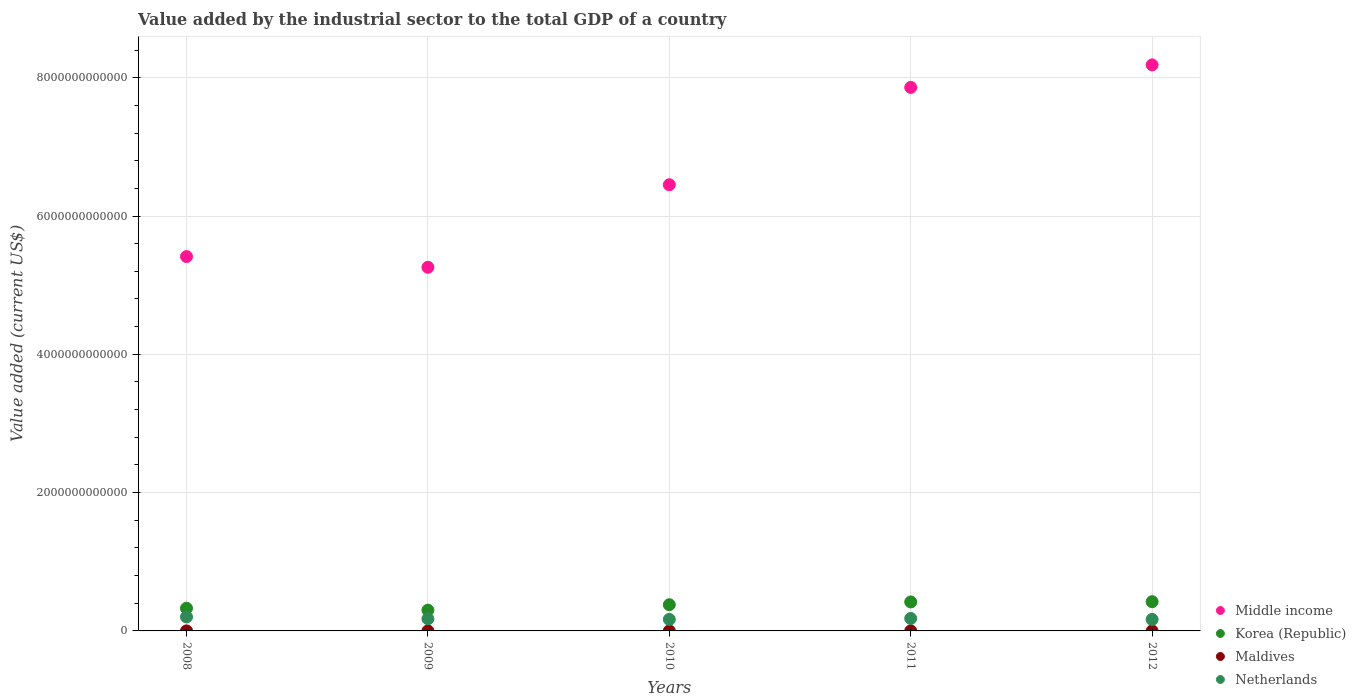Is the number of dotlines equal to the number of legend labels?
Provide a succinct answer. Yes. What is the value added by the industrial sector to the total GDP in Netherlands in 2010?
Provide a succinct answer. 1.66e+11. Across all years, what is the maximum value added by the industrial sector to the total GDP in Maldives?
Your answer should be very brief. 4.31e+08. Across all years, what is the minimum value added by the industrial sector to the total GDP in Middle income?
Make the answer very short. 5.26e+12. In which year was the value added by the industrial sector to the total GDP in Middle income minimum?
Your response must be concise. 2009. What is the total value added by the industrial sector to the total GDP in Korea (Republic) in the graph?
Keep it short and to the point. 1.85e+12. What is the difference between the value added by the industrial sector to the total GDP in Netherlands in 2008 and that in 2009?
Ensure brevity in your answer.  2.69e+1. What is the difference between the value added by the industrial sector to the total GDP in Netherlands in 2008 and the value added by the industrial sector to the total GDP in Maldives in 2012?
Give a very brief answer. 2.02e+11. What is the average value added by the industrial sector to the total GDP in Netherlands per year?
Provide a succinct answer. 1.78e+11. In the year 2012, what is the difference between the value added by the industrial sector to the total GDP in Korea (Republic) and value added by the industrial sector to the total GDP in Netherlands?
Provide a succinct answer. 2.57e+11. In how many years, is the value added by the industrial sector to the total GDP in Maldives greater than 4400000000000 US$?
Your answer should be compact. 0. What is the ratio of the value added by the industrial sector to the total GDP in Korea (Republic) in 2011 to that in 2012?
Offer a terse response. 0.99. What is the difference between the highest and the second highest value added by the industrial sector to the total GDP in Maldives?
Provide a succinct answer. 2.55e+07. What is the difference between the highest and the lowest value added by the industrial sector to the total GDP in Netherlands?
Your answer should be compact. 3.62e+1. Is the sum of the value added by the industrial sector to the total GDP in Middle income in 2010 and 2011 greater than the maximum value added by the industrial sector to the total GDP in Maldives across all years?
Make the answer very short. Yes. Is it the case that in every year, the sum of the value added by the industrial sector to the total GDP in Middle income and value added by the industrial sector to the total GDP in Korea (Republic)  is greater than the sum of value added by the industrial sector to the total GDP in Netherlands and value added by the industrial sector to the total GDP in Maldives?
Offer a very short reply. Yes. Is it the case that in every year, the sum of the value added by the industrial sector to the total GDP in Middle income and value added by the industrial sector to the total GDP in Korea (Republic)  is greater than the value added by the industrial sector to the total GDP in Maldives?
Ensure brevity in your answer.  Yes. Is the value added by the industrial sector to the total GDP in Maldives strictly greater than the value added by the industrial sector to the total GDP in Middle income over the years?
Your response must be concise. No. What is the difference between two consecutive major ticks on the Y-axis?
Keep it short and to the point. 2.00e+12. Does the graph contain grids?
Give a very brief answer. Yes. Where does the legend appear in the graph?
Offer a terse response. Bottom right. How many legend labels are there?
Offer a very short reply. 4. How are the legend labels stacked?
Ensure brevity in your answer.  Vertical. What is the title of the graph?
Provide a succinct answer. Value added by the industrial sector to the total GDP of a country. Does "Fiji" appear as one of the legend labels in the graph?
Your response must be concise. No. What is the label or title of the X-axis?
Your answer should be compact. Years. What is the label or title of the Y-axis?
Your answer should be compact. Value added (current US$). What is the Value added (current US$) in Middle income in 2008?
Your answer should be very brief. 5.41e+12. What is the Value added (current US$) of Korea (Republic) in 2008?
Your answer should be very brief. 3.28e+11. What is the Value added (current US$) of Maldives in 2008?
Ensure brevity in your answer.  3.41e+08. What is the Value added (current US$) of Netherlands in 2008?
Offer a very short reply. 2.02e+11. What is the Value added (current US$) of Middle income in 2009?
Keep it short and to the point. 5.26e+12. What is the Value added (current US$) of Korea (Republic) in 2009?
Your answer should be very brief. 3.00e+11. What is the Value added (current US$) of Maldives in 2009?
Your answer should be very brief. 2.99e+08. What is the Value added (current US$) of Netherlands in 2009?
Make the answer very short. 1.75e+11. What is the Value added (current US$) in Middle income in 2010?
Your answer should be compact. 6.45e+12. What is the Value added (current US$) of Korea (Republic) in 2010?
Offer a very short reply. 3.79e+11. What is the Value added (current US$) in Maldives in 2010?
Make the answer very short. 3.32e+08. What is the Value added (current US$) in Netherlands in 2010?
Provide a succinct answer. 1.66e+11. What is the Value added (current US$) of Middle income in 2011?
Your answer should be compact. 7.86e+12. What is the Value added (current US$) of Korea (Republic) in 2011?
Your answer should be very brief. 4.19e+11. What is the Value added (current US$) in Maldives in 2011?
Offer a very short reply. 4.06e+08. What is the Value added (current US$) of Netherlands in 2011?
Make the answer very short. 1.80e+11. What is the Value added (current US$) in Middle income in 2012?
Make the answer very short. 8.19e+12. What is the Value added (current US$) of Korea (Republic) in 2012?
Make the answer very short. 4.23e+11. What is the Value added (current US$) of Maldives in 2012?
Your answer should be very brief. 4.31e+08. What is the Value added (current US$) in Netherlands in 2012?
Provide a succinct answer. 1.66e+11. Across all years, what is the maximum Value added (current US$) of Middle income?
Offer a terse response. 8.19e+12. Across all years, what is the maximum Value added (current US$) in Korea (Republic)?
Offer a very short reply. 4.23e+11. Across all years, what is the maximum Value added (current US$) of Maldives?
Offer a very short reply. 4.31e+08. Across all years, what is the maximum Value added (current US$) of Netherlands?
Make the answer very short. 2.02e+11. Across all years, what is the minimum Value added (current US$) in Middle income?
Keep it short and to the point. 5.26e+12. Across all years, what is the minimum Value added (current US$) of Korea (Republic)?
Offer a very short reply. 3.00e+11. Across all years, what is the minimum Value added (current US$) in Maldives?
Ensure brevity in your answer.  2.99e+08. Across all years, what is the minimum Value added (current US$) of Netherlands?
Offer a very short reply. 1.66e+11. What is the total Value added (current US$) of Middle income in the graph?
Provide a succinct answer. 3.32e+13. What is the total Value added (current US$) in Korea (Republic) in the graph?
Your answer should be compact. 1.85e+12. What is the total Value added (current US$) in Maldives in the graph?
Give a very brief answer. 1.81e+09. What is the total Value added (current US$) in Netherlands in the graph?
Your response must be concise. 8.91e+11. What is the difference between the Value added (current US$) of Middle income in 2008 and that in 2009?
Offer a very short reply. 1.55e+11. What is the difference between the Value added (current US$) in Korea (Republic) in 2008 and that in 2009?
Your response must be concise. 2.79e+1. What is the difference between the Value added (current US$) in Maldives in 2008 and that in 2009?
Your answer should be very brief. 4.22e+07. What is the difference between the Value added (current US$) of Netherlands in 2008 and that in 2009?
Ensure brevity in your answer.  2.69e+1. What is the difference between the Value added (current US$) of Middle income in 2008 and that in 2010?
Your answer should be compact. -1.04e+12. What is the difference between the Value added (current US$) in Korea (Republic) in 2008 and that in 2010?
Keep it short and to the point. -5.11e+1. What is the difference between the Value added (current US$) of Maldives in 2008 and that in 2010?
Provide a succinct answer. 9.53e+06. What is the difference between the Value added (current US$) of Netherlands in 2008 and that in 2010?
Give a very brief answer. 3.58e+1. What is the difference between the Value added (current US$) in Middle income in 2008 and that in 2011?
Ensure brevity in your answer.  -2.45e+12. What is the difference between the Value added (current US$) of Korea (Republic) in 2008 and that in 2011?
Offer a very short reply. -9.11e+1. What is the difference between the Value added (current US$) in Maldives in 2008 and that in 2011?
Keep it short and to the point. -6.45e+07. What is the difference between the Value added (current US$) in Netherlands in 2008 and that in 2011?
Provide a succinct answer. 2.19e+1. What is the difference between the Value added (current US$) in Middle income in 2008 and that in 2012?
Keep it short and to the point. -2.77e+12. What is the difference between the Value added (current US$) in Korea (Republic) in 2008 and that in 2012?
Give a very brief answer. -9.50e+1. What is the difference between the Value added (current US$) of Maldives in 2008 and that in 2012?
Provide a succinct answer. -9.00e+07. What is the difference between the Value added (current US$) in Netherlands in 2008 and that in 2012?
Provide a short and direct response. 3.62e+1. What is the difference between the Value added (current US$) of Middle income in 2009 and that in 2010?
Offer a terse response. -1.19e+12. What is the difference between the Value added (current US$) of Korea (Republic) in 2009 and that in 2010?
Keep it short and to the point. -7.90e+1. What is the difference between the Value added (current US$) in Maldives in 2009 and that in 2010?
Your answer should be compact. -3.27e+07. What is the difference between the Value added (current US$) of Netherlands in 2009 and that in 2010?
Offer a terse response. 8.91e+09. What is the difference between the Value added (current US$) of Middle income in 2009 and that in 2011?
Provide a short and direct response. -2.60e+12. What is the difference between the Value added (current US$) in Korea (Republic) in 2009 and that in 2011?
Make the answer very short. -1.19e+11. What is the difference between the Value added (current US$) in Maldives in 2009 and that in 2011?
Your response must be concise. -1.07e+08. What is the difference between the Value added (current US$) in Netherlands in 2009 and that in 2011?
Offer a terse response. -5.02e+09. What is the difference between the Value added (current US$) in Middle income in 2009 and that in 2012?
Give a very brief answer. -2.93e+12. What is the difference between the Value added (current US$) of Korea (Republic) in 2009 and that in 2012?
Offer a very short reply. -1.23e+11. What is the difference between the Value added (current US$) in Maldives in 2009 and that in 2012?
Offer a very short reply. -1.32e+08. What is the difference between the Value added (current US$) of Netherlands in 2009 and that in 2012?
Your answer should be very brief. 9.27e+09. What is the difference between the Value added (current US$) in Middle income in 2010 and that in 2011?
Offer a very short reply. -1.41e+12. What is the difference between the Value added (current US$) of Korea (Republic) in 2010 and that in 2011?
Offer a very short reply. -3.99e+1. What is the difference between the Value added (current US$) in Maldives in 2010 and that in 2011?
Offer a very short reply. -7.41e+07. What is the difference between the Value added (current US$) in Netherlands in 2010 and that in 2011?
Give a very brief answer. -1.39e+1. What is the difference between the Value added (current US$) of Middle income in 2010 and that in 2012?
Your answer should be compact. -1.73e+12. What is the difference between the Value added (current US$) in Korea (Republic) in 2010 and that in 2012?
Your answer should be compact. -4.39e+1. What is the difference between the Value added (current US$) in Maldives in 2010 and that in 2012?
Provide a succinct answer. -9.95e+07. What is the difference between the Value added (current US$) in Netherlands in 2010 and that in 2012?
Make the answer very short. 3.54e+08. What is the difference between the Value added (current US$) of Middle income in 2011 and that in 2012?
Ensure brevity in your answer.  -3.26e+11. What is the difference between the Value added (current US$) in Korea (Republic) in 2011 and that in 2012?
Offer a terse response. -3.92e+09. What is the difference between the Value added (current US$) of Maldives in 2011 and that in 2012?
Provide a short and direct response. -2.55e+07. What is the difference between the Value added (current US$) in Netherlands in 2011 and that in 2012?
Your response must be concise. 1.43e+1. What is the difference between the Value added (current US$) of Middle income in 2008 and the Value added (current US$) of Korea (Republic) in 2009?
Keep it short and to the point. 5.11e+12. What is the difference between the Value added (current US$) of Middle income in 2008 and the Value added (current US$) of Maldives in 2009?
Your answer should be compact. 5.41e+12. What is the difference between the Value added (current US$) in Middle income in 2008 and the Value added (current US$) in Netherlands in 2009?
Ensure brevity in your answer.  5.24e+12. What is the difference between the Value added (current US$) in Korea (Republic) in 2008 and the Value added (current US$) in Maldives in 2009?
Offer a very short reply. 3.28e+11. What is the difference between the Value added (current US$) in Korea (Republic) in 2008 and the Value added (current US$) in Netherlands in 2009?
Your answer should be very brief. 1.53e+11. What is the difference between the Value added (current US$) in Maldives in 2008 and the Value added (current US$) in Netherlands in 2009?
Offer a very short reply. -1.75e+11. What is the difference between the Value added (current US$) of Middle income in 2008 and the Value added (current US$) of Korea (Republic) in 2010?
Provide a succinct answer. 5.03e+12. What is the difference between the Value added (current US$) of Middle income in 2008 and the Value added (current US$) of Maldives in 2010?
Provide a short and direct response. 5.41e+12. What is the difference between the Value added (current US$) in Middle income in 2008 and the Value added (current US$) in Netherlands in 2010?
Offer a very short reply. 5.25e+12. What is the difference between the Value added (current US$) in Korea (Republic) in 2008 and the Value added (current US$) in Maldives in 2010?
Provide a succinct answer. 3.28e+11. What is the difference between the Value added (current US$) in Korea (Republic) in 2008 and the Value added (current US$) in Netherlands in 2010?
Provide a short and direct response. 1.61e+11. What is the difference between the Value added (current US$) in Maldives in 2008 and the Value added (current US$) in Netherlands in 2010?
Offer a terse response. -1.66e+11. What is the difference between the Value added (current US$) in Middle income in 2008 and the Value added (current US$) in Korea (Republic) in 2011?
Your answer should be very brief. 4.99e+12. What is the difference between the Value added (current US$) in Middle income in 2008 and the Value added (current US$) in Maldives in 2011?
Your answer should be compact. 5.41e+12. What is the difference between the Value added (current US$) in Middle income in 2008 and the Value added (current US$) in Netherlands in 2011?
Give a very brief answer. 5.23e+12. What is the difference between the Value added (current US$) of Korea (Republic) in 2008 and the Value added (current US$) of Maldives in 2011?
Keep it short and to the point. 3.28e+11. What is the difference between the Value added (current US$) of Korea (Republic) in 2008 and the Value added (current US$) of Netherlands in 2011?
Provide a succinct answer. 1.48e+11. What is the difference between the Value added (current US$) in Maldives in 2008 and the Value added (current US$) in Netherlands in 2011?
Your response must be concise. -1.80e+11. What is the difference between the Value added (current US$) of Middle income in 2008 and the Value added (current US$) of Korea (Republic) in 2012?
Provide a short and direct response. 4.99e+12. What is the difference between the Value added (current US$) of Middle income in 2008 and the Value added (current US$) of Maldives in 2012?
Keep it short and to the point. 5.41e+12. What is the difference between the Value added (current US$) in Middle income in 2008 and the Value added (current US$) in Netherlands in 2012?
Ensure brevity in your answer.  5.25e+12. What is the difference between the Value added (current US$) in Korea (Republic) in 2008 and the Value added (current US$) in Maldives in 2012?
Ensure brevity in your answer.  3.28e+11. What is the difference between the Value added (current US$) of Korea (Republic) in 2008 and the Value added (current US$) of Netherlands in 2012?
Provide a succinct answer. 1.62e+11. What is the difference between the Value added (current US$) in Maldives in 2008 and the Value added (current US$) in Netherlands in 2012?
Ensure brevity in your answer.  -1.66e+11. What is the difference between the Value added (current US$) in Middle income in 2009 and the Value added (current US$) in Korea (Republic) in 2010?
Give a very brief answer. 4.88e+12. What is the difference between the Value added (current US$) in Middle income in 2009 and the Value added (current US$) in Maldives in 2010?
Your answer should be compact. 5.26e+12. What is the difference between the Value added (current US$) in Middle income in 2009 and the Value added (current US$) in Netherlands in 2010?
Keep it short and to the point. 5.09e+12. What is the difference between the Value added (current US$) of Korea (Republic) in 2009 and the Value added (current US$) of Maldives in 2010?
Make the answer very short. 3.00e+11. What is the difference between the Value added (current US$) in Korea (Republic) in 2009 and the Value added (current US$) in Netherlands in 2010?
Offer a terse response. 1.34e+11. What is the difference between the Value added (current US$) of Maldives in 2009 and the Value added (current US$) of Netherlands in 2010?
Make the answer very short. -1.66e+11. What is the difference between the Value added (current US$) of Middle income in 2009 and the Value added (current US$) of Korea (Republic) in 2011?
Make the answer very short. 4.84e+12. What is the difference between the Value added (current US$) of Middle income in 2009 and the Value added (current US$) of Maldives in 2011?
Your answer should be compact. 5.26e+12. What is the difference between the Value added (current US$) in Middle income in 2009 and the Value added (current US$) in Netherlands in 2011?
Offer a terse response. 5.08e+12. What is the difference between the Value added (current US$) in Korea (Republic) in 2009 and the Value added (current US$) in Maldives in 2011?
Provide a short and direct response. 3.00e+11. What is the difference between the Value added (current US$) in Korea (Republic) in 2009 and the Value added (current US$) in Netherlands in 2011?
Offer a terse response. 1.20e+11. What is the difference between the Value added (current US$) of Maldives in 2009 and the Value added (current US$) of Netherlands in 2011?
Your answer should be very brief. -1.80e+11. What is the difference between the Value added (current US$) in Middle income in 2009 and the Value added (current US$) in Korea (Republic) in 2012?
Provide a succinct answer. 4.84e+12. What is the difference between the Value added (current US$) of Middle income in 2009 and the Value added (current US$) of Maldives in 2012?
Offer a very short reply. 5.26e+12. What is the difference between the Value added (current US$) of Middle income in 2009 and the Value added (current US$) of Netherlands in 2012?
Ensure brevity in your answer.  5.09e+12. What is the difference between the Value added (current US$) in Korea (Republic) in 2009 and the Value added (current US$) in Maldives in 2012?
Offer a very short reply. 3.00e+11. What is the difference between the Value added (current US$) in Korea (Republic) in 2009 and the Value added (current US$) in Netherlands in 2012?
Ensure brevity in your answer.  1.34e+11. What is the difference between the Value added (current US$) in Maldives in 2009 and the Value added (current US$) in Netherlands in 2012?
Your answer should be very brief. -1.66e+11. What is the difference between the Value added (current US$) of Middle income in 2010 and the Value added (current US$) of Korea (Republic) in 2011?
Make the answer very short. 6.03e+12. What is the difference between the Value added (current US$) of Middle income in 2010 and the Value added (current US$) of Maldives in 2011?
Your answer should be compact. 6.45e+12. What is the difference between the Value added (current US$) in Middle income in 2010 and the Value added (current US$) in Netherlands in 2011?
Keep it short and to the point. 6.27e+12. What is the difference between the Value added (current US$) of Korea (Republic) in 2010 and the Value added (current US$) of Maldives in 2011?
Your answer should be compact. 3.79e+11. What is the difference between the Value added (current US$) of Korea (Republic) in 2010 and the Value added (current US$) of Netherlands in 2011?
Make the answer very short. 1.99e+11. What is the difference between the Value added (current US$) in Maldives in 2010 and the Value added (current US$) in Netherlands in 2011?
Make the answer very short. -1.80e+11. What is the difference between the Value added (current US$) of Middle income in 2010 and the Value added (current US$) of Korea (Republic) in 2012?
Provide a short and direct response. 6.03e+12. What is the difference between the Value added (current US$) in Middle income in 2010 and the Value added (current US$) in Maldives in 2012?
Provide a short and direct response. 6.45e+12. What is the difference between the Value added (current US$) in Middle income in 2010 and the Value added (current US$) in Netherlands in 2012?
Ensure brevity in your answer.  6.29e+12. What is the difference between the Value added (current US$) of Korea (Republic) in 2010 and the Value added (current US$) of Maldives in 2012?
Offer a very short reply. 3.79e+11. What is the difference between the Value added (current US$) in Korea (Republic) in 2010 and the Value added (current US$) in Netherlands in 2012?
Give a very brief answer. 2.13e+11. What is the difference between the Value added (current US$) in Maldives in 2010 and the Value added (current US$) in Netherlands in 2012?
Keep it short and to the point. -1.66e+11. What is the difference between the Value added (current US$) of Middle income in 2011 and the Value added (current US$) of Korea (Republic) in 2012?
Offer a terse response. 7.44e+12. What is the difference between the Value added (current US$) of Middle income in 2011 and the Value added (current US$) of Maldives in 2012?
Offer a very short reply. 7.86e+12. What is the difference between the Value added (current US$) of Middle income in 2011 and the Value added (current US$) of Netherlands in 2012?
Your answer should be compact. 7.69e+12. What is the difference between the Value added (current US$) in Korea (Republic) in 2011 and the Value added (current US$) in Maldives in 2012?
Your response must be concise. 4.19e+11. What is the difference between the Value added (current US$) of Korea (Republic) in 2011 and the Value added (current US$) of Netherlands in 2012?
Offer a terse response. 2.53e+11. What is the difference between the Value added (current US$) in Maldives in 2011 and the Value added (current US$) in Netherlands in 2012?
Offer a very short reply. -1.66e+11. What is the average Value added (current US$) of Middle income per year?
Provide a succinct answer. 6.63e+12. What is the average Value added (current US$) of Korea (Republic) per year?
Make the answer very short. 3.70e+11. What is the average Value added (current US$) of Maldives per year?
Your response must be concise. 3.62e+08. What is the average Value added (current US$) in Netherlands per year?
Ensure brevity in your answer.  1.78e+11. In the year 2008, what is the difference between the Value added (current US$) of Middle income and Value added (current US$) of Korea (Republic)?
Offer a very short reply. 5.09e+12. In the year 2008, what is the difference between the Value added (current US$) in Middle income and Value added (current US$) in Maldives?
Provide a short and direct response. 5.41e+12. In the year 2008, what is the difference between the Value added (current US$) in Middle income and Value added (current US$) in Netherlands?
Offer a terse response. 5.21e+12. In the year 2008, what is the difference between the Value added (current US$) of Korea (Republic) and Value added (current US$) of Maldives?
Ensure brevity in your answer.  3.28e+11. In the year 2008, what is the difference between the Value added (current US$) of Korea (Republic) and Value added (current US$) of Netherlands?
Provide a succinct answer. 1.26e+11. In the year 2008, what is the difference between the Value added (current US$) in Maldives and Value added (current US$) in Netherlands?
Your response must be concise. -2.02e+11. In the year 2009, what is the difference between the Value added (current US$) of Middle income and Value added (current US$) of Korea (Republic)?
Your answer should be compact. 4.96e+12. In the year 2009, what is the difference between the Value added (current US$) of Middle income and Value added (current US$) of Maldives?
Ensure brevity in your answer.  5.26e+12. In the year 2009, what is the difference between the Value added (current US$) in Middle income and Value added (current US$) in Netherlands?
Your answer should be compact. 5.08e+12. In the year 2009, what is the difference between the Value added (current US$) of Korea (Republic) and Value added (current US$) of Maldives?
Your answer should be compact. 3.00e+11. In the year 2009, what is the difference between the Value added (current US$) of Korea (Republic) and Value added (current US$) of Netherlands?
Make the answer very short. 1.25e+11. In the year 2009, what is the difference between the Value added (current US$) of Maldives and Value added (current US$) of Netherlands?
Offer a very short reply. -1.75e+11. In the year 2010, what is the difference between the Value added (current US$) in Middle income and Value added (current US$) in Korea (Republic)?
Keep it short and to the point. 6.07e+12. In the year 2010, what is the difference between the Value added (current US$) in Middle income and Value added (current US$) in Maldives?
Provide a succinct answer. 6.45e+12. In the year 2010, what is the difference between the Value added (current US$) in Middle income and Value added (current US$) in Netherlands?
Give a very brief answer. 6.29e+12. In the year 2010, what is the difference between the Value added (current US$) of Korea (Republic) and Value added (current US$) of Maldives?
Your answer should be compact. 3.79e+11. In the year 2010, what is the difference between the Value added (current US$) of Korea (Republic) and Value added (current US$) of Netherlands?
Give a very brief answer. 2.13e+11. In the year 2010, what is the difference between the Value added (current US$) of Maldives and Value added (current US$) of Netherlands?
Keep it short and to the point. -1.66e+11. In the year 2011, what is the difference between the Value added (current US$) of Middle income and Value added (current US$) of Korea (Republic)?
Your answer should be very brief. 7.44e+12. In the year 2011, what is the difference between the Value added (current US$) of Middle income and Value added (current US$) of Maldives?
Provide a short and direct response. 7.86e+12. In the year 2011, what is the difference between the Value added (current US$) of Middle income and Value added (current US$) of Netherlands?
Your answer should be very brief. 7.68e+12. In the year 2011, what is the difference between the Value added (current US$) of Korea (Republic) and Value added (current US$) of Maldives?
Provide a short and direct response. 4.19e+11. In the year 2011, what is the difference between the Value added (current US$) of Korea (Republic) and Value added (current US$) of Netherlands?
Offer a very short reply. 2.39e+11. In the year 2011, what is the difference between the Value added (current US$) in Maldives and Value added (current US$) in Netherlands?
Keep it short and to the point. -1.80e+11. In the year 2012, what is the difference between the Value added (current US$) in Middle income and Value added (current US$) in Korea (Republic)?
Your answer should be very brief. 7.76e+12. In the year 2012, what is the difference between the Value added (current US$) in Middle income and Value added (current US$) in Maldives?
Provide a succinct answer. 8.19e+12. In the year 2012, what is the difference between the Value added (current US$) of Middle income and Value added (current US$) of Netherlands?
Make the answer very short. 8.02e+12. In the year 2012, what is the difference between the Value added (current US$) of Korea (Republic) and Value added (current US$) of Maldives?
Provide a short and direct response. 4.23e+11. In the year 2012, what is the difference between the Value added (current US$) of Korea (Republic) and Value added (current US$) of Netherlands?
Your answer should be very brief. 2.57e+11. In the year 2012, what is the difference between the Value added (current US$) of Maldives and Value added (current US$) of Netherlands?
Keep it short and to the point. -1.66e+11. What is the ratio of the Value added (current US$) in Middle income in 2008 to that in 2009?
Your response must be concise. 1.03. What is the ratio of the Value added (current US$) of Korea (Republic) in 2008 to that in 2009?
Provide a short and direct response. 1.09. What is the ratio of the Value added (current US$) of Maldives in 2008 to that in 2009?
Offer a very short reply. 1.14. What is the ratio of the Value added (current US$) of Netherlands in 2008 to that in 2009?
Your answer should be compact. 1.15. What is the ratio of the Value added (current US$) of Middle income in 2008 to that in 2010?
Offer a very short reply. 0.84. What is the ratio of the Value added (current US$) of Korea (Republic) in 2008 to that in 2010?
Provide a short and direct response. 0.87. What is the ratio of the Value added (current US$) of Maldives in 2008 to that in 2010?
Keep it short and to the point. 1.03. What is the ratio of the Value added (current US$) of Netherlands in 2008 to that in 2010?
Your answer should be compact. 1.22. What is the ratio of the Value added (current US$) in Middle income in 2008 to that in 2011?
Your answer should be compact. 0.69. What is the ratio of the Value added (current US$) in Korea (Republic) in 2008 to that in 2011?
Your response must be concise. 0.78. What is the ratio of the Value added (current US$) in Maldives in 2008 to that in 2011?
Give a very brief answer. 0.84. What is the ratio of the Value added (current US$) in Netherlands in 2008 to that in 2011?
Offer a terse response. 1.12. What is the ratio of the Value added (current US$) in Middle income in 2008 to that in 2012?
Your answer should be very brief. 0.66. What is the ratio of the Value added (current US$) of Korea (Republic) in 2008 to that in 2012?
Provide a short and direct response. 0.78. What is the ratio of the Value added (current US$) in Maldives in 2008 to that in 2012?
Your answer should be very brief. 0.79. What is the ratio of the Value added (current US$) in Netherlands in 2008 to that in 2012?
Your answer should be compact. 1.22. What is the ratio of the Value added (current US$) of Middle income in 2009 to that in 2010?
Offer a terse response. 0.81. What is the ratio of the Value added (current US$) in Korea (Republic) in 2009 to that in 2010?
Your answer should be very brief. 0.79. What is the ratio of the Value added (current US$) in Maldives in 2009 to that in 2010?
Keep it short and to the point. 0.9. What is the ratio of the Value added (current US$) of Netherlands in 2009 to that in 2010?
Offer a very short reply. 1.05. What is the ratio of the Value added (current US$) of Middle income in 2009 to that in 2011?
Give a very brief answer. 0.67. What is the ratio of the Value added (current US$) of Korea (Republic) in 2009 to that in 2011?
Keep it short and to the point. 0.72. What is the ratio of the Value added (current US$) of Maldives in 2009 to that in 2011?
Offer a terse response. 0.74. What is the ratio of the Value added (current US$) of Netherlands in 2009 to that in 2011?
Provide a short and direct response. 0.97. What is the ratio of the Value added (current US$) of Middle income in 2009 to that in 2012?
Give a very brief answer. 0.64. What is the ratio of the Value added (current US$) in Korea (Republic) in 2009 to that in 2012?
Provide a succinct answer. 0.71. What is the ratio of the Value added (current US$) of Maldives in 2009 to that in 2012?
Provide a succinct answer. 0.69. What is the ratio of the Value added (current US$) in Netherlands in 2009 to that in 2012?
Keep it short and to the point. 1.06. What is the ratio of the Value added (current US$) in Middle income in 2010 to that in 2011?
Your answer should be very brief. 0.82. What is the ratio of the Value added (current US$) of Korea (Republic) in 2010 to that in 2011?
Provide a short and direct response. 0.9. What is the ratio of the Value added (current US$) in Maldives in 2010 to that in 2011?
Your answer should be compact. 0.82. What is the ratio of the Value added (current US$) of Netherlands in 2010 to that in 2011?
Ensure brevity in your answer.  0.92. What is the ratio of the Value added (current US$) in Middle income in 2010 to that in 2012?
Offer a very short reply. 0.79. What is the ratio of the Value added (current US$) of Korea (Republic) in 2010 to that in 2012?
Provide a short and direct response. 0.9. What is the ratio of the Value added (current US$) of Maldives in 2010 to that in 2012?
Offer a terse response. 0.77. What is the ratio of the Value added (current US$) of Netherlands in 2010 to that in 2012?
Your response must be concise. 1. What is the ratio of the Value added (current US$) of Middle income in 2011 to that in 2012?
Your answer should be compact. 0.96. What is the ratio of the Value added (current US$) in Korea (Republic) in 2011 to that in 2012?
Provide a succinct answer. 0.99. What is the ratio of the Value added (current US$) in Maldives in 2011 to that in 2012?
Your answer should be compact. 0.94. What is the ratio of the Value added (current US$) of Netherlands in 2011 to that in 2012?
Offer a terse response. 1.09. What is the difference between the highest and the second highest Value added (current US$) in Middle income?
Provide a succinct answer. 3.26e+11. What is the difference between the highest and the second highest Value added (current US$) of Korea (Republic)?
Provide a succinct answer. 3.92e+09. What is the difference between the highest and the second highest Value added (current US$) in Maldives?
Keep it short and to the point. 2.55e+07. What is the difference between the highest and the second highest Value added (current US$) in Netherlands?
Provide a succinct answer. 2.19e+1. What is the difference between the highest and the lowest Value added (current US$) in Middle income?
Offer a terse response. 2.93e+12. What is the difference between the highest and the lowest Value added (current US$) in Korea (Republic)?
Your answer should be very brief. 1.23e+11. What is the difference between the highest and the lowest Value added (current US$) in Maldives?
Provide a short and direct response. 1.32e+08. What is the difference between the highest and the lowest Value added (current US$) in Netherlands?
Ensure brevity in your answer.  3.62e+1. 